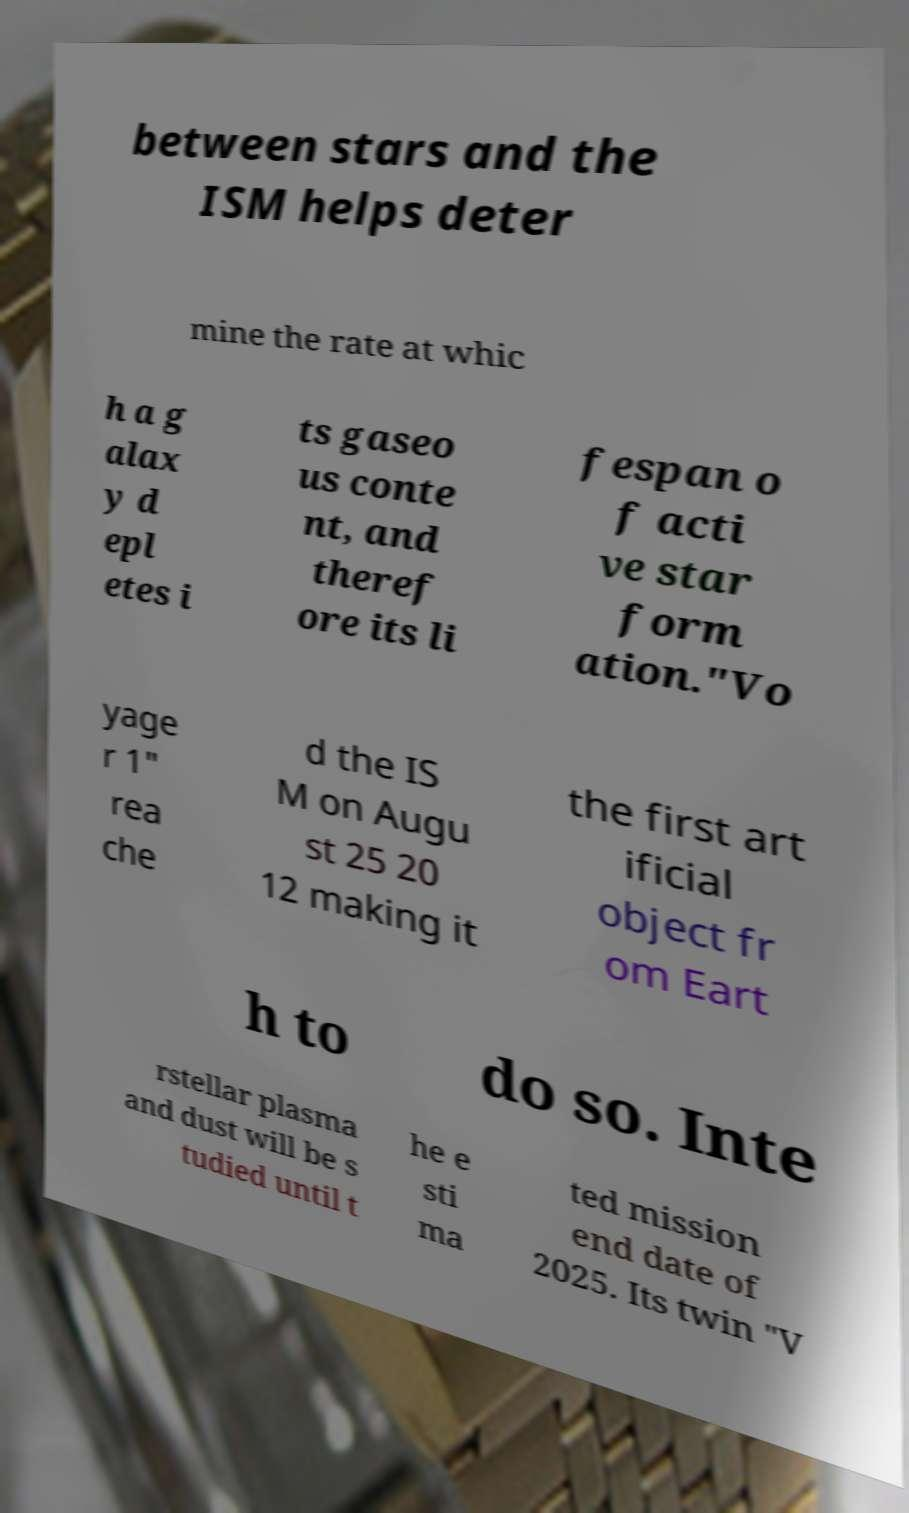Could you assist in decoding the text presented in this image and type it out clearly? between stars and the ISM helps deter mine the rate at whic h a g alax y d epl etes i ts gaseo us conte nt, and theref ore its li fespan o f acti ve star form ation."Vo yage r 1" rea che d the IS M on Augu st 25 20 12 making it the first art ificial object fr om Eart h to do so. Inte rstellar plasma and dust will be s tudied until t he e sti ma ted mission end date of 2025. Its twin "V 